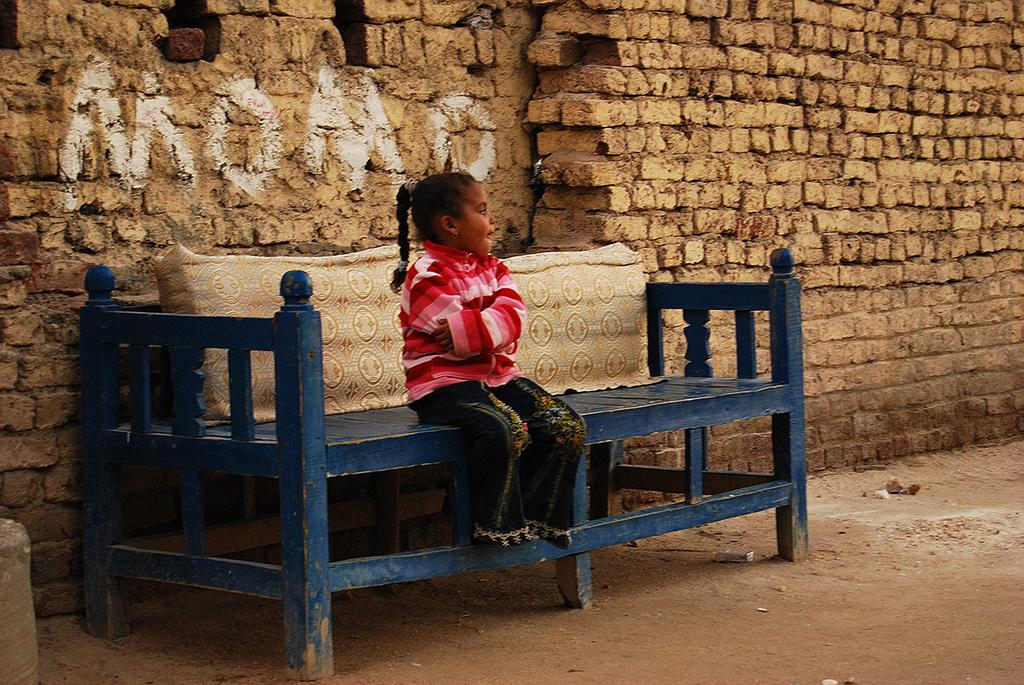What is the main subject of the image? The main subject of the image is a small kid. Where is the kid sitting in the image? The kid is sitting on a blue wooden bench. What can be seen behind the bench in the image? There is a brick wall behind the bench. How many apples are on the ground near the kid in the image? There are no apples present in the image. What type of band is playing music in the background of the image? There is no band present in the image. 